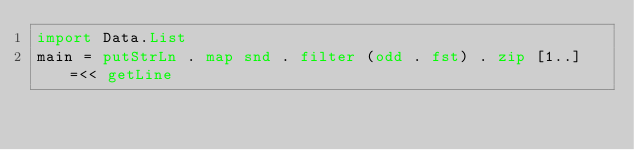<code> <loc_0><loc_0><loc_500><loc_500><_Haskell_>import Data.List
main = putStrLn . map snd . filter (odd . fst) . zip [1..] =<< getLine
</code> 